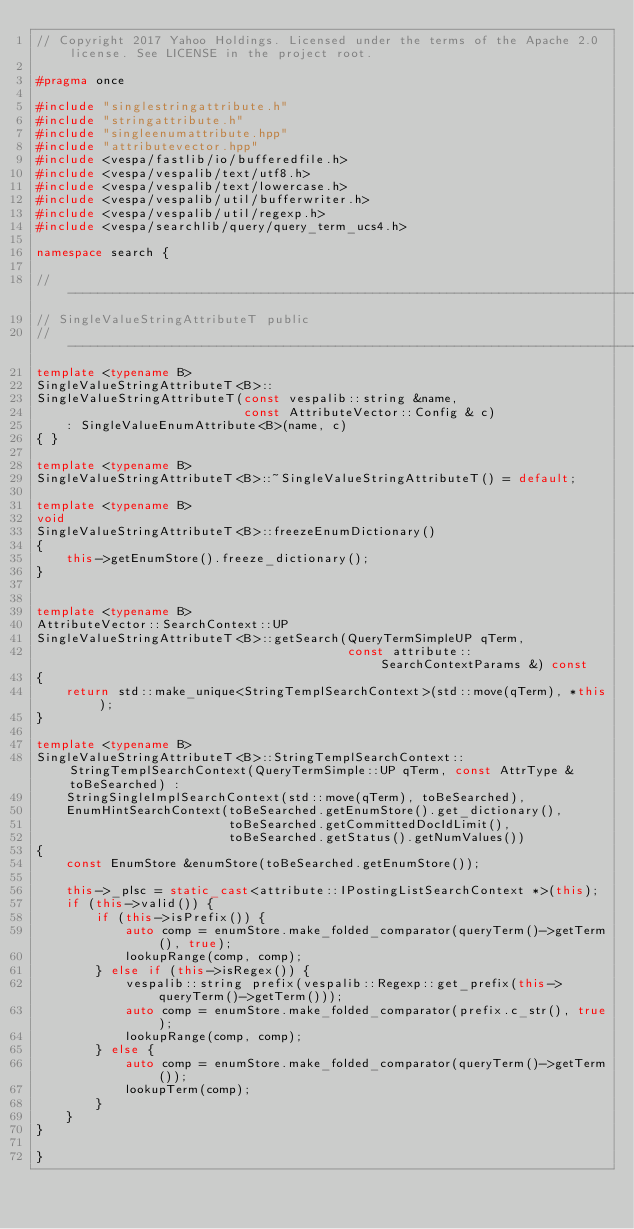<code> <loc_0><loc_0><loc_500><loc_500><_C++_>// Copyright 2017 Yahoo Holdings. Licensed under the terms of the Apache 2.0 license. See LICENSE in the project root.

#pragma once

#include "singlestringattribute.h"
#include "stringattribute.h"
#include "singleenumattribute.hpp"
#include "attributevector.hpp"
#include <vespa/fastlib/io/bufferedfile.h>
#include <vespa/vespalib/text/utf8.h>
#include <vespa/vespalib/text/lowercase.h>
#include <vespa/vespalib/util/bufferwriter.h>
#include <vespa/vespalib/util/regexp.h>
#include <vespa/searchlib/query/query_term_ucs4.h>

namespace search {

//-----------------------------------------------------------------------------
// SingleValueStringAttributeT public
//-----------------------------------------------------------------------------
template <typename B>
SingleValueStringAttributeT<B>::
SingleValueStringAttributeT(const vespalib::string &name,
                            const AttributeVector::Config & c)
    : SingleValueEnumAttribute<B>(name, c)
{ }

template <typename B>
SingleValueStringAttributeT<B>::~SingleValueStringAttributeT() = default;

template <typename B>
void
SingleValueStringAttributeT<B>::freezeEnumDictionary()
{
    this->getEnumStore().freeze_dictionary();
}


template <typename B>
AttributeVector::SearchContext::UP
SingleValueStringAttributeT<B>::getSearch(QueryTermSimpleUP qTerm,
                                          const attribute::SearchContextParams &) const
{
    return std::make_unique<StringTemplSearchContext>(std::move(qTerm), *this);
}

template <typename B>
SingleValueStringAttributeT<B>::StringTemplSearchContext::StringTemplSearchContext(QueryTermSimple::UP qTerm, const AttrType & toBeSearched) :
    StringSingleImplSearchContext(std::move(qTerm), toBeSearched),
    EnumHintSearchContext(toBeSearched.getEnumStore().get_dictionary(),
                          toBeSearched.getCommittedDocIdLimit(),
                          toBeSearched.getStatus().getNumValues())
{
    const EnumStore &enumStore(toBeSearched.getEnumStore());

    this->_plsc = static_cast<attribute::IPostingListSearchContext *>(this);
    if (this->valid()) {
        if (this->isPrefix()) {
            auto comp = enumStore.make_folded_comparator(queryTerm()->getTerm(), true);
            lookupRange(comp, comp);
        } else if (this->isRegex()) {
            vespalib::string prefix(vespalib::Regexp::get_prefix(this->queryTerm()->getTerm()));
            auto comp = enumStore.make_folded_comparator(prefix.c_str(), true);
            lookupRange(comp, comp);
        } else {
            auto comp = enumStore.make_folded_comparator(queryTerm()->getTerm());
            lookupTerm(comp);
        }
    }
}

}
</code> 